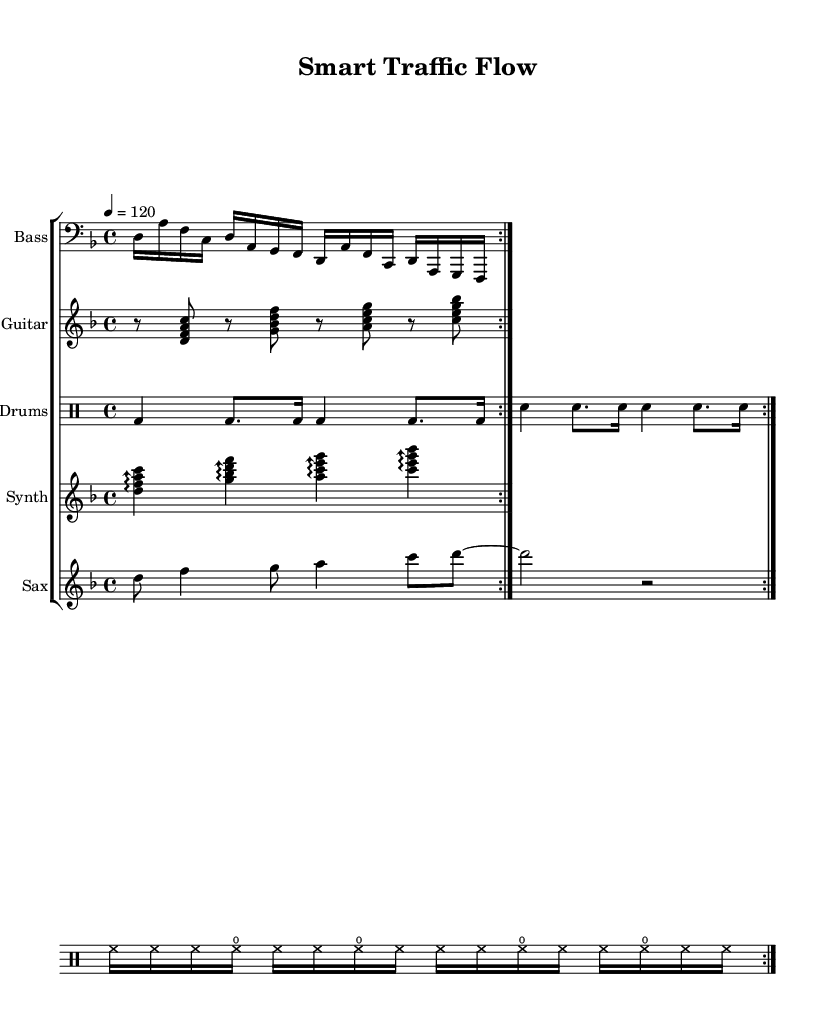What is the key signature of this music? The key signature is indicated by the number of sharps or flats at the beginning of the staff. Here, there are no sharps or flats, indicating it is in D minor, which has one flat.
Answer: D minor What is the time signature of this music? The time signature is located at the beginning of the staff. It shows 4 over 4, indicating four beats per measure.
Answer: 4/4 What is the tempo marking for this piece? The tempo is shown with the notation above the staff, indicating the speed of the piece. Here, it states "4 = 120," meaning there are 120 beats per minute.
Answer: 120 How many instruments are part of the score? To find the number of instruments, we count the individual staves labeled in the score. There are five different staves for the bass, guitar, drums, synth, and sax.
Answer: 5 What type of rhythm pattern do the drums play? The drum part consists of the bass drum (bd), snare drum (sn), and hi-hat (hh) played in a groove, characterized by repeated patterns that contribute to the funk feel. It reveals a complex and syncopated rhythm typical of funk-fusion music.
Answer: Funk groove Which instrument plays the melody? The melody is typically found in the part with a recognizable sequence of notes. Here, the saxophone staff contains the melody line featuring distinct pitches and rhythms.
Answer: Saxophone What is the relationship between the bass line and the rhythm of the music? The bass line plays a supportive role that complements the overall groove, establishing the foundation of rhythm. In funk-fusion, it often syncs with the drum pattern to create a cohesive flow, analogous to how traffic systems optimize movement.
Answer: Syncopated groove 